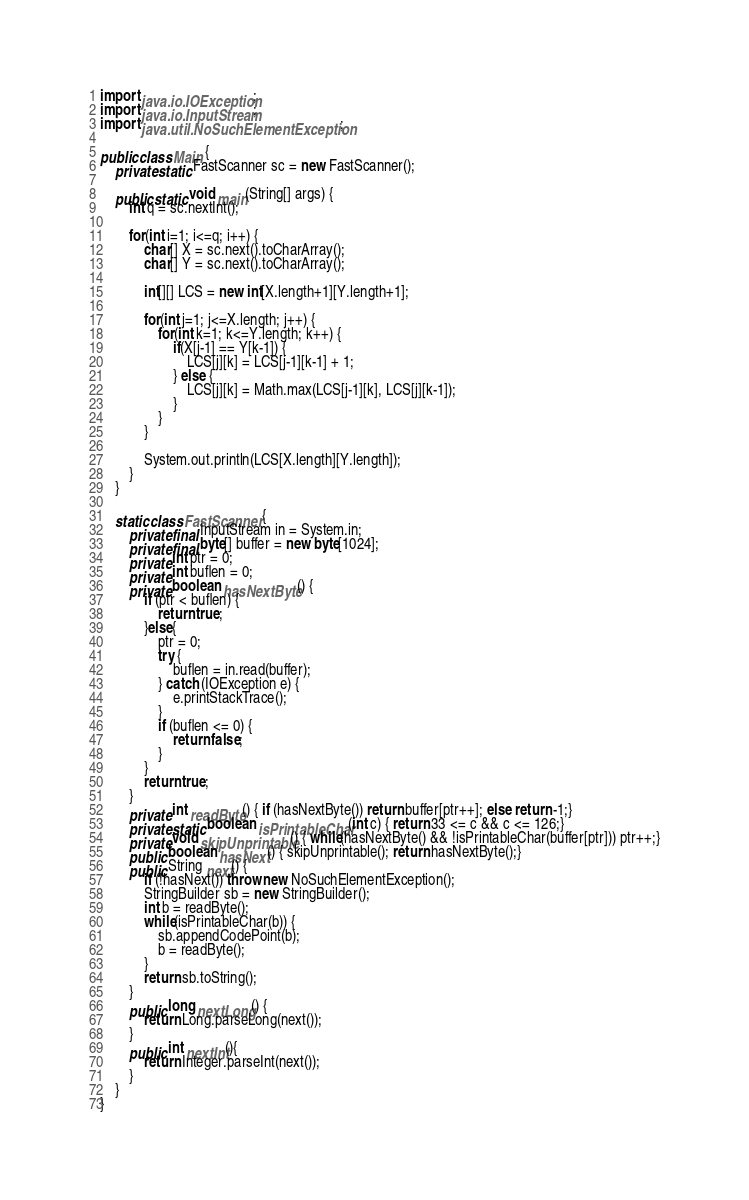<code> <loc_0><loc_0><loc_500><loc_500><_Java_>import java.io.IOException;
import java.io.InputStream;
import java.util.NoSuchElementException;

public class Main {
	private static FastScanner sc = new FastScanner();

	public static void main(String[] args) {
		int q = sc.nextInt();
		
		for(int i=1; i<=q; i++) {
			char[] X = sc.next().toCharArray();
			char[] Y = sc.next().toCharArray();
			
			int[][] LCS = new int[X.length+1][Y.length+1];
			
			for(int j=1; j<=X.length; j++) {
				for(int k=1; k<=Y.length; k++) {
					if(X[j-1] == Y[k-1]) {
						LCS[j][k] = LCS[j-1][k-1] + 1;
					} else {
						LCS[j][k] = Math.max(LCS[j-1][k], LCS[j][k-1]);
					}
				}
			}
			
			System.out.println(LCS[X.length][Y.length]);
		}
	}

	static class FastScanner {
	    private final InputStream in = System.in;
	    private final byte[] buffer = new byte[1024];
	    private int ptr = 0;
	    private int buflen = 0;
	    private boolean hasNextByte() {
	        if (ptr < buflen) {
	            return true;
	        }else{
	            ptr = 0;
	            try {
	                buflen = in.read(buffer);
	            } catch (IOException e) {
	                e.printStackTrace();
	            }
	            if (buflen <= 0) {
	                return false;
	            }
	        }
	        return true;
	    }
	    private int readByte() { if (hasNextByte()) return buffer[ptr++]; else return -1;}
	    private static boolean isPrintableChar(int c) { return 33 <= c && c <= 126;}
	    private void skipUnprintable() { while(hasNextByte() && !isPrintableChar(buffer[ptr])) ptr++;}
	    public boolean hasNext() { skipUnprintable(); return hasNextByte();}
	    public String next() {
	        if (!hasNext()) throw new NoSuchElementException();
	        StringBuilder sb = new StringBuilder();
	        int b = readByte();
	        while(isPrintableChar(b)) {
	            sb.appendCodePoint(b);
	            b = readByte();
	        }
	        return sb.toString();
	    }
	    public long nextLong() {
	        return Long.parseLong(next());
	    }
	    public int nextInt(){
	    	return Integer.parseInt(next());
	    }
	}
}</code> 